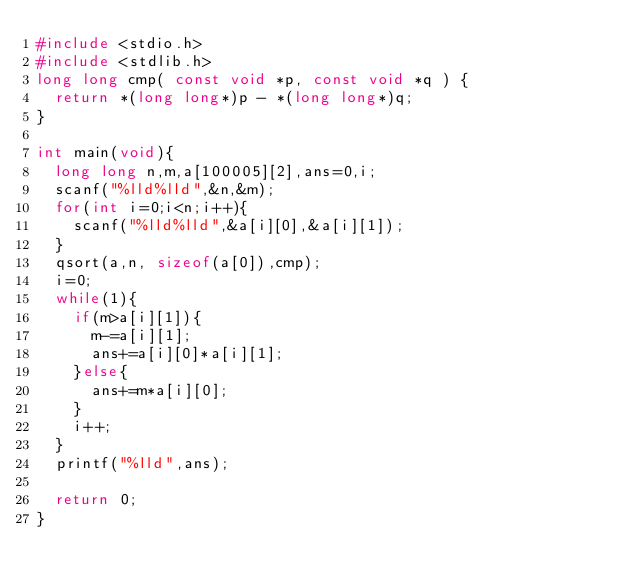Convert code to text. <code><loc_0><loc_0><loc_500><loc_500><_C_>#include <stdio.h>
#include <stdlib.h>
long long cmp( const void *p, const void *q ) {
  return *(long long*)p - *(long long*)q;
}

int main(void){
  long long n,m,a[100005][2],ans=0,i;
  scanf("%lld%lld",&n,&m);
  for(int i=0;i<n;i++){
    scanf("%lld%lld",&a[i][0],&a[i][1]);
  }
  qsort(a,n, sizeof(a[0]),cmp);
  i=0;
  while(1){
    if(m>a[i][1]){
      m-=a[i][1];
      ans+=a[i][0]*a[i][1];
    }else{
      ans+=m*a[i][0];
    }
    i++;
  }
  printf("%lld",ans);

  return 0;
}</code> 